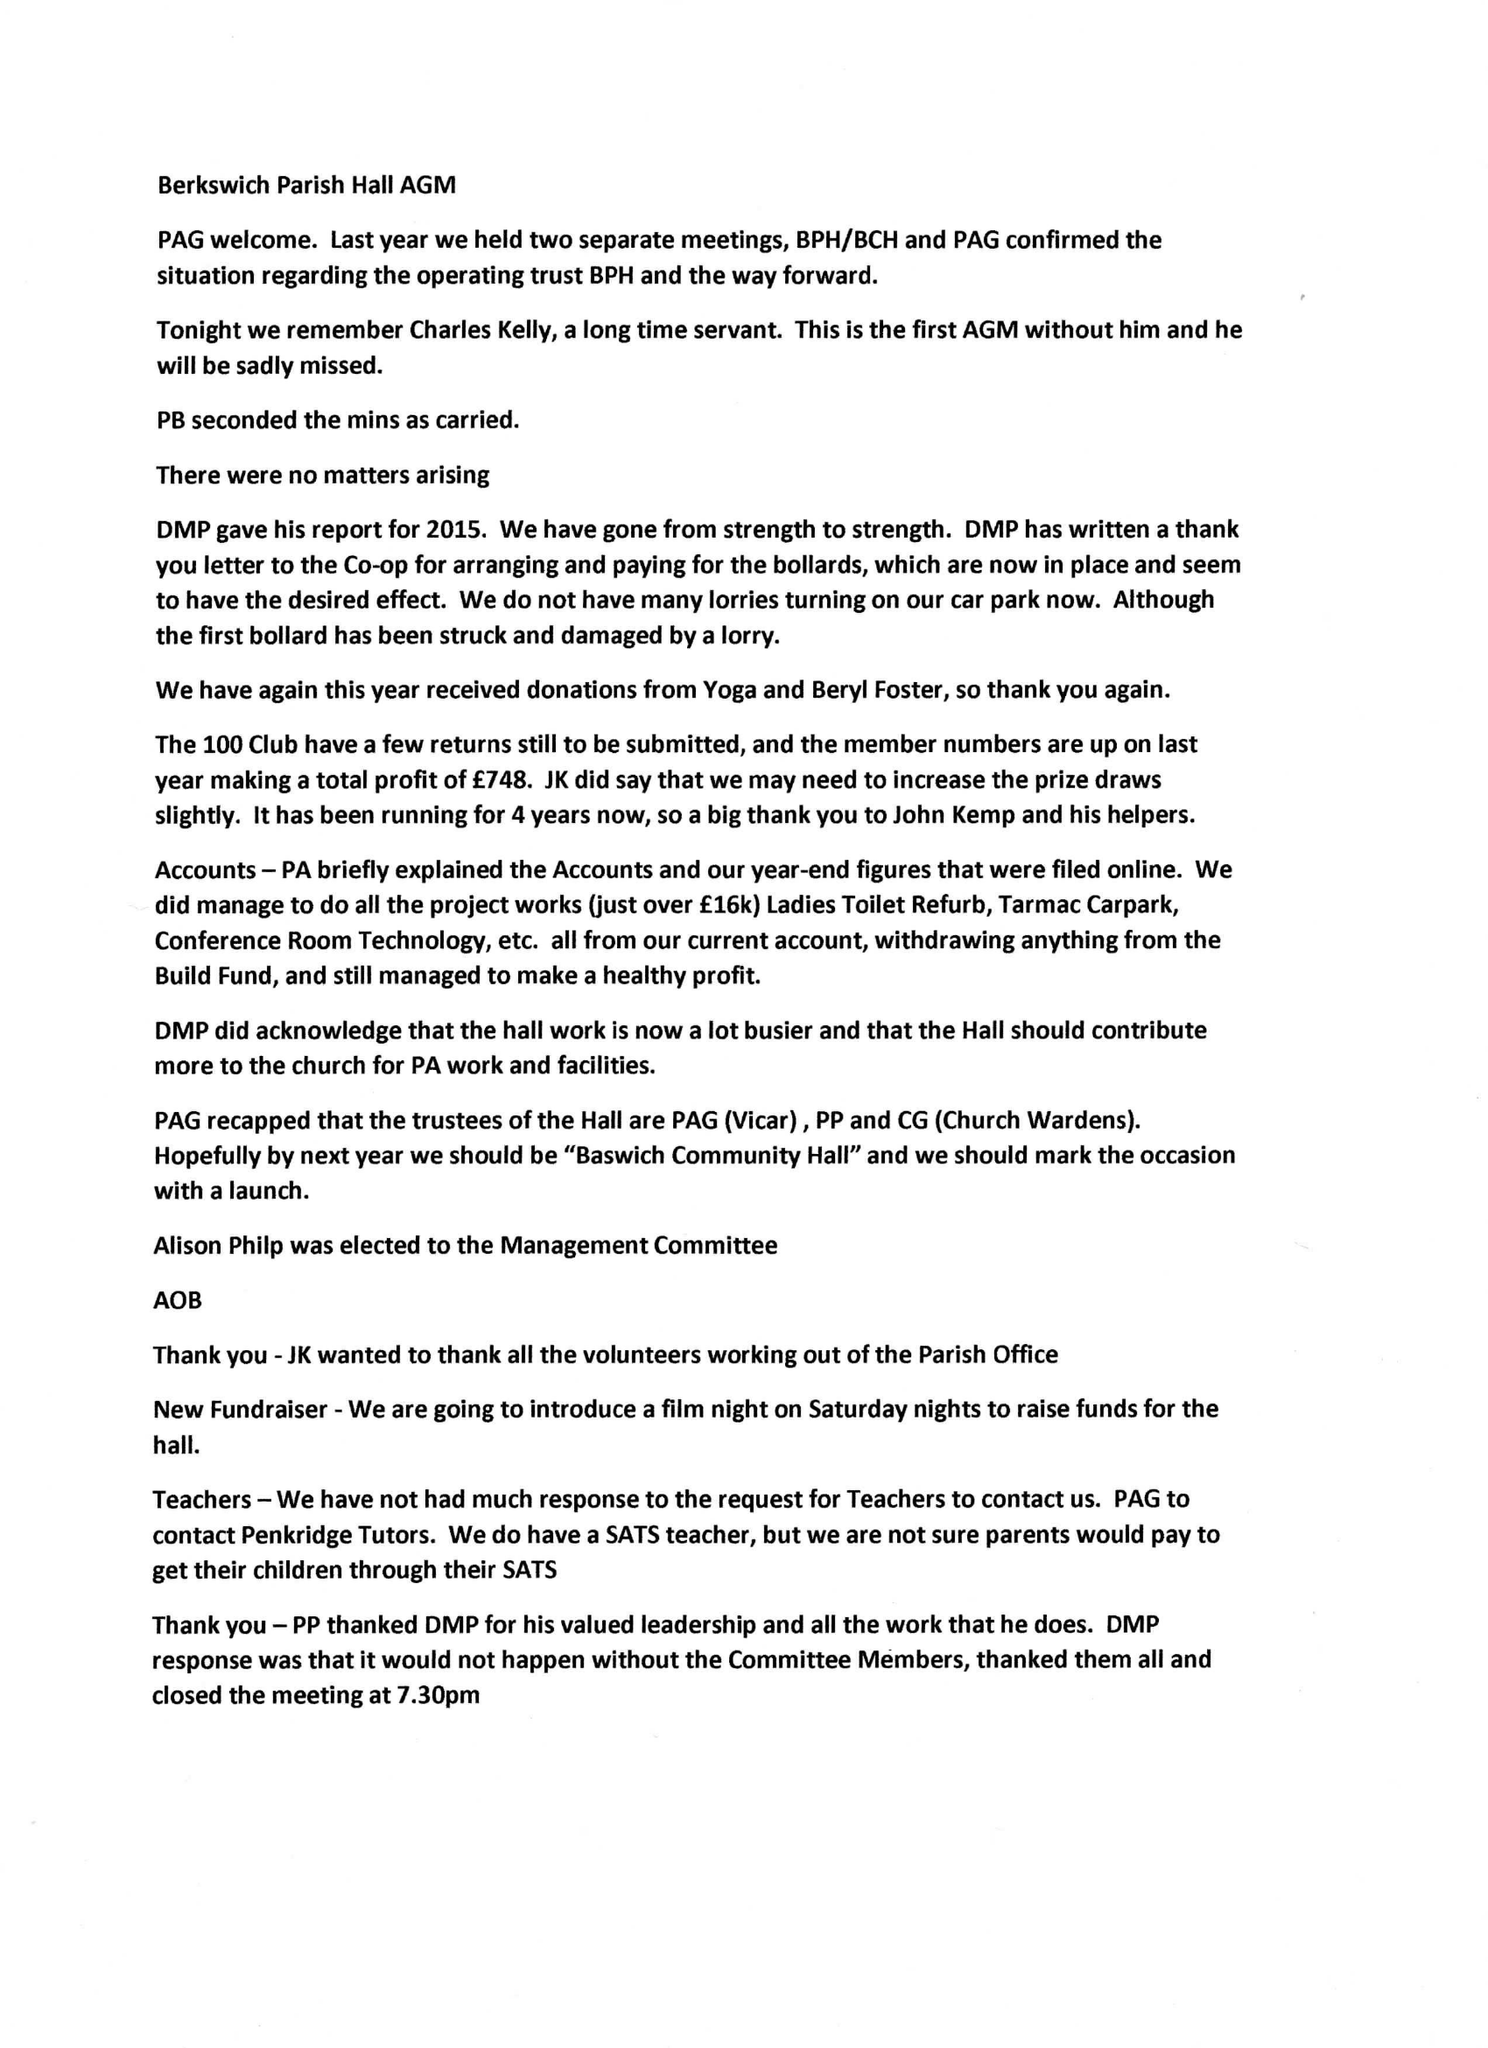What is the value for the address__post_town?
Answer the question using a single word or phrase. STAFFORD 